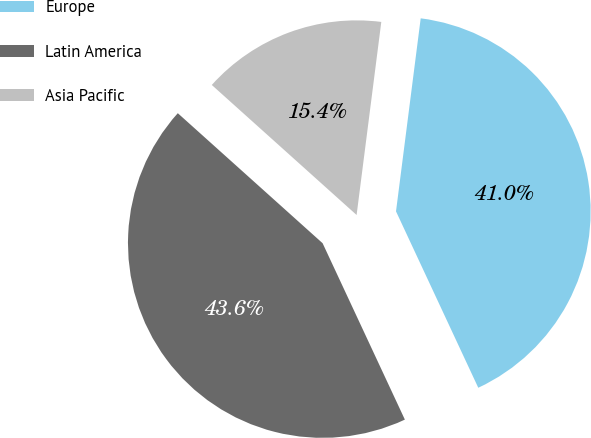<chart> <loc_0><loc_0><loc_500><loc_500><pie_chart><fcel>Europe<fcel>Latin America<fcel>Asia Pacific<nl><fcel>41.03%<fcel>43.59%<fcel>15.38%<nl></chart> 